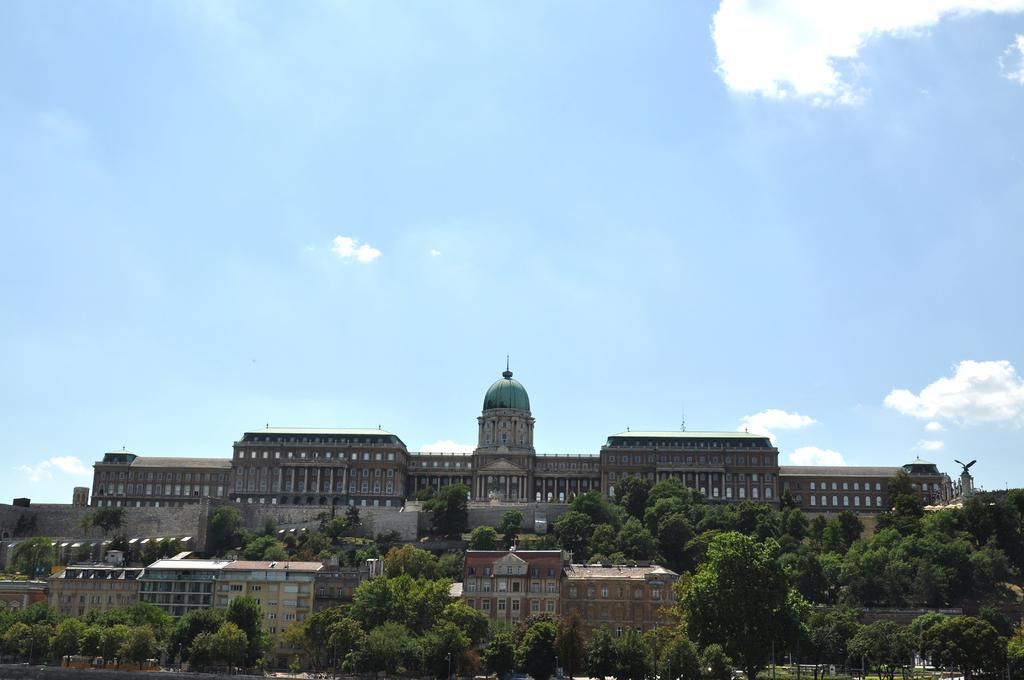What type of structures can be seen in the image? There are buildings in the image. What is located in front of the buildings? There are trees in front of the buildings. What can be seen in the background of the image? The sky is visible in the background of the image. What type of beetle can be seen crawling on the authority figure in the image? There is no beetle or authority figure present in the image. What role does the father play in the image? There is no father present in the image. 